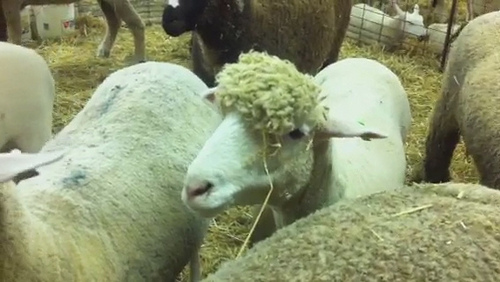What place was the photo taken at? The photo was taken in a pen. 